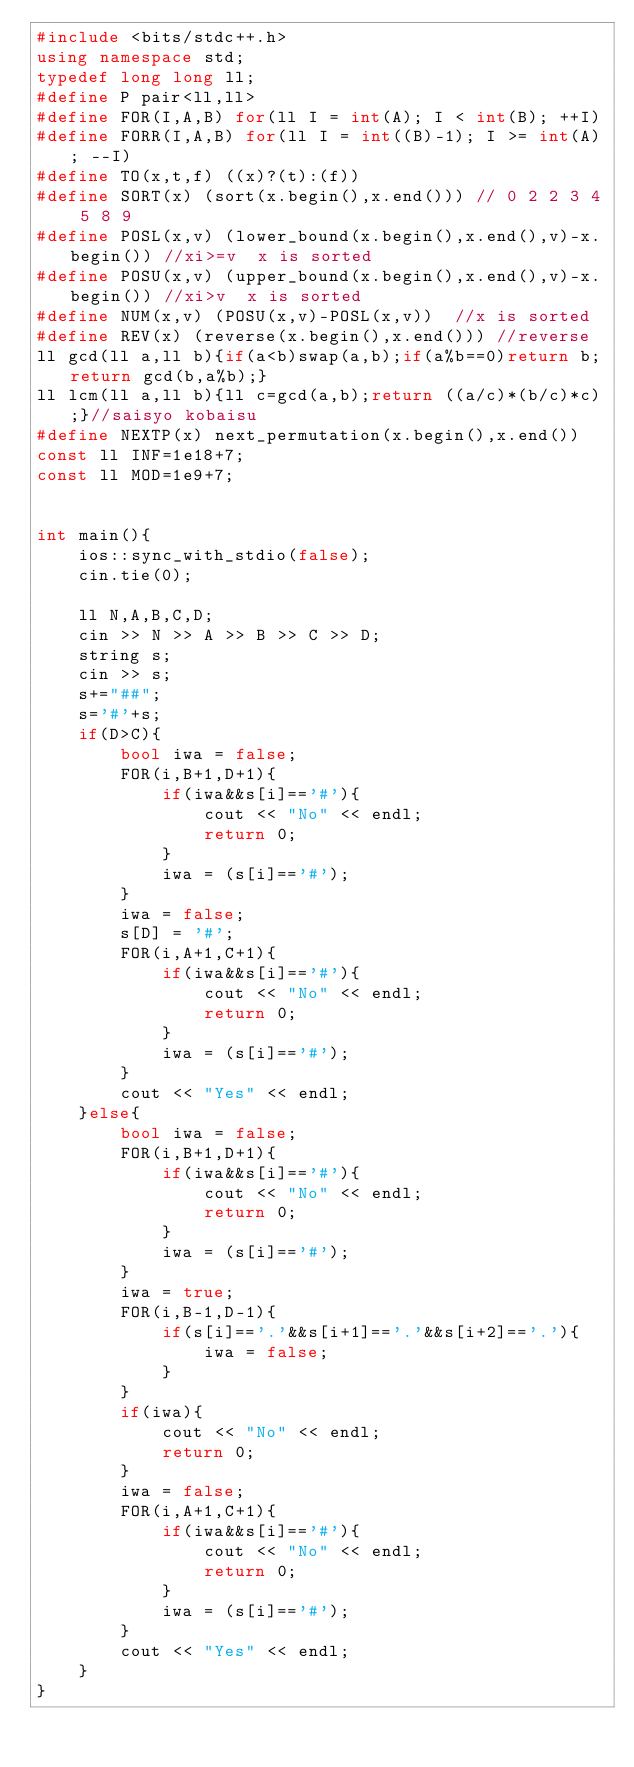<code> <loc_0><loc_0><loc_500><loc_500><_C++_>#include <bits/stdc++.h>
using namespace std;
typedef long long ll;
#define P pair<ll,ll>
#define FOR(I,A,B) for(ll I = int(A); I < int(B); ++I)
#define FORR(I,A,B) for(ll I = int((B)-1); I >= int(A); --I)
#define TO(x,t,f) ((x)?(t):(f))
#define SORT(x) (sort(x.begin(),x.end())) // 0 2 2 3 4 5 8 9
#define POSL(x,v) (lower_bound(x.begin(),x.end(),v)-x.begin()) //xi>=v  x is sorted
#define POSU(x,v) (upper_bound(x.begin(),x.end(),v)-x.begin()) //xi>v  x is sorted
#define NUM(x,v) (POSU(x,v)-POSL(x,v))  //x is sorted
#define REV(x) (reverse(x.begin(),x.end())) //reverse
ll gcd(ll a,ll b){if(a<b)swap(a,b);if(a%b==0)return b;return gcd(b,a%b);}
ll lcm(ll a,ll b){ll c=gcd(a,b);return ((a/c)*(b/c)*c);}//saisyo kobaisu
#define NEXTP(x) next_permutation(x.begin(),x.end())
const ll INF=1e18+7;
const ll MOD=1e9+7;


int main(){
	ios::sync_with_stdio(false);
	cin.tie(0);

	ll N,A,B,C,D;
	cin >> N >> A >> B >> C >> D;
	string s;
	cin >> s;
	s+="##";
	s='#'+s;
	if(D>C){
		bool iwa = false;
		FOR(i,B+1,D+1){
			if(iwa&&s[i]=='#'){
				cout << "No" << endl;
				return 0;
			}
			iwa = (s[i]=='#');
		}
		iwa = false;
		s[D] = '#';
		FOR(i,A+1,C+1){
			if(iwa&&s[i]=='#'){
				cout << "No" << endl;
				return 0;
			}
			iwa = (s[i]=='#');
		}
		cout << "Yes" << endl;
	}else{
		bool iwa = false;
		FOR(i,B+1,D+1){
			if(iwa&&s[i]=='#'){
				cout << "No" << endl;
				return 0;
			}
			iwa = (s[i]=='#');
		}
		iwa = true;
		FOR(i,B-1,D-1){
			if(s[i]=='.'&&s[i+1]=='.'&&s[i+2]=='.'){
				iwa = false;
			}
		}
		if(iwa){
			cout << "No" << endl;
			return 0;
		}
		iwa = false;
		FOR(i,A+1,C+1){
			if(iwa&&s[i]=='#'){
				cout << "No" << endl;
				return 0;
			}
			iwa = (s[i]=='#');
		}
		cout << "Yes" << endl;
	}
}
</code> 